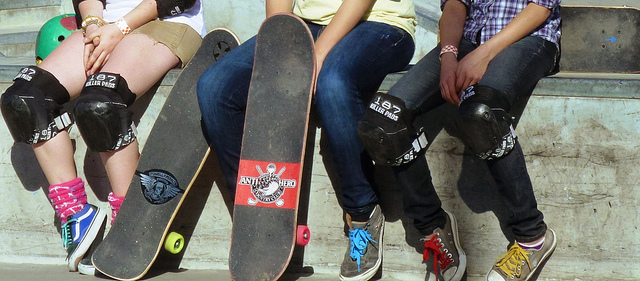Please transcribe the text information in this image. 187 187 18 